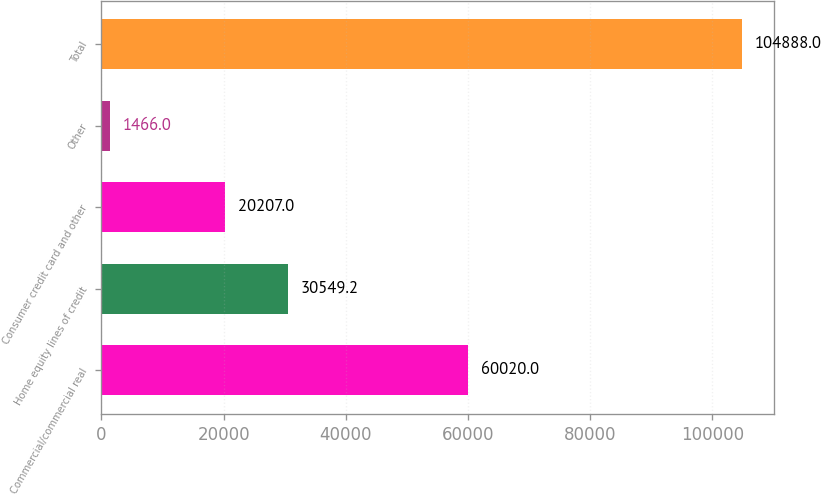<chart> <loc_0><loc_0><loc_500><loc_500><bar_chart><fcel>Commercial/commercial real<fcel>Home equity lines of credit<fcel>Consumer credit card and other<fcel>Other<fcel>Total<nl><fcel>60020<fcel>30549.2<fcel>20207<fcel>1466<fcel>104888<nl></chart> 